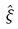Convert formula to latex. <formula><loc_0><loc_0><loc_500><loc_500>\hat { \xi }</formula> 